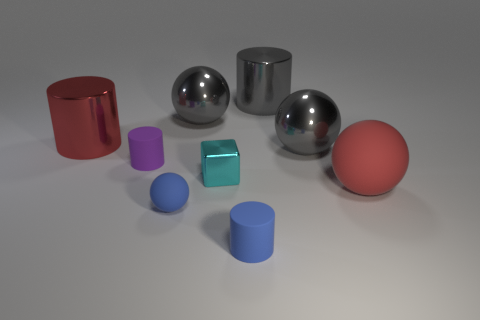Subtract all gray shiny cylinders. How many cylinders are left? 3 Add 1 green matte things. How many objects exist? 10 Subtract 2 balls. How many balls are left? 2 Subtract all red spheres. How many spheres are left? 3 Subtract all balls. How many objects are left? 5 Subtract all cyan spheres. How many blue cylinders are left? 1 Subtract all gray shiny cubes. Subtract all large gray cylinders. How many objects are left? 8 Add 3 balls. How many balls are left? 7 Add 1 big objects. How many big objects exist? 6 Subtract 1 blue cylinders. How many objects are left? 8 